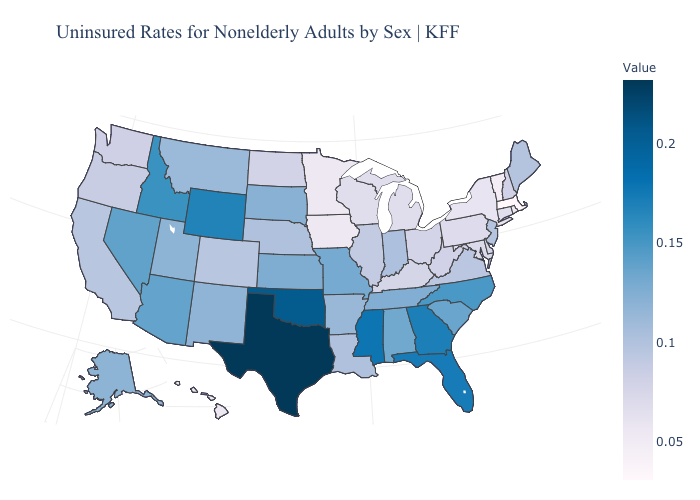Does Massachusetts have the lowest value in the Northeast?
Write a very short answer. Yes. Does Nebraska have the highest value in the USA?
Concise answer only. No. Is the legend a continuous bar?
Give a very brief answer. Yes. Does Tennessee have a higher value than Wyoming?
Short answer required. No. Does Massachusetts have the lowest value in the USA?
Write a very short answer. Yes. 